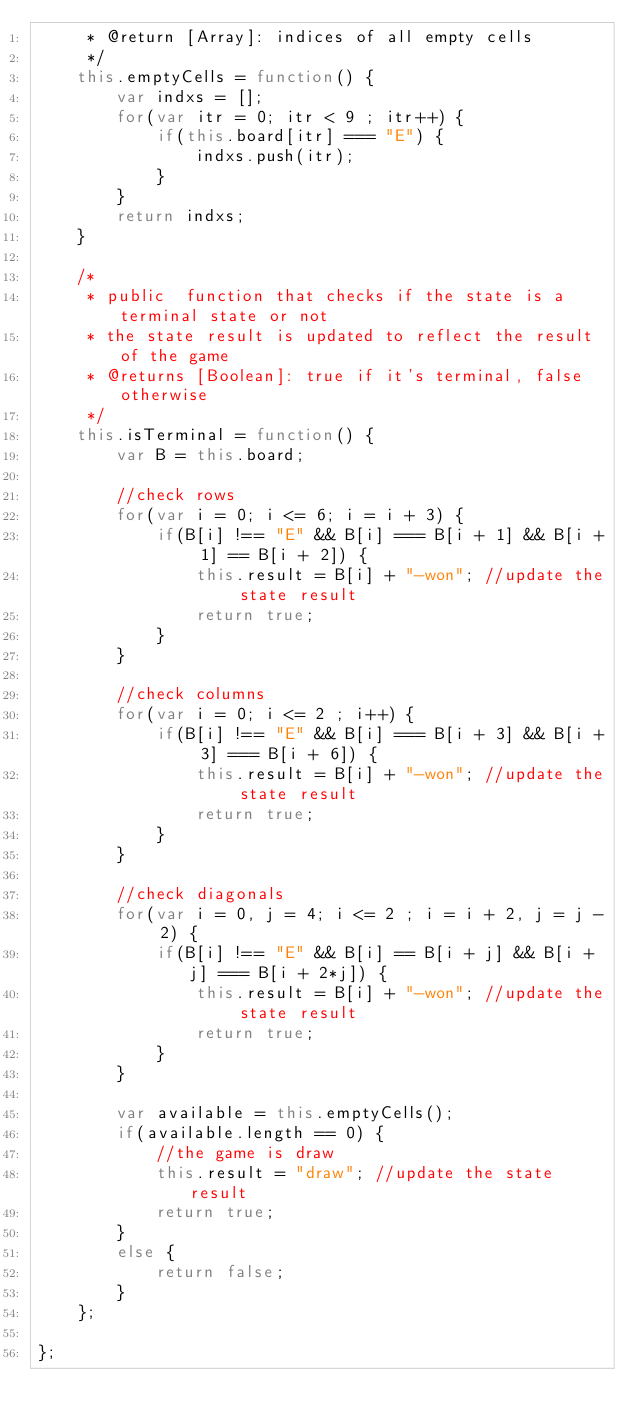Convert code to text. <code><loc_0><loc_0><loc_500><loc_500><_JavaScript_>     * @return [Array]: indices of all empty cells
     */
    this.emptyCells = function() {
        var indxs = [];
        for(var itr = 0; itr < 9 ; itr++) {
            if(this.board[itr] === "E") {
                indxs.push(itr);
            }
        }
        return indxs;
    }

    /*
     * public  function that checks if the state is a terminal state or not
     * the state result is updated to reflect the result of the game
     * @returns [Boolean]: true if it's terminal, false otherwise
     */
    this.isTerminal = function() {
        var B = this.board;

        //check rows
        for(var i = 0; i <= 6; i = i + 3) {
            if(B[i] !== "E" && B[i] === B[i + 1] && B[i + 1] == B[i + 2]) {
                this.result = B[i] + "-won"; //update the state result
                return true;
            }
        }

        //check columns
        for(var i = 0; i <= 2 ; i++) {
            if(B[i] !== "E" && B[i] === B[i + 3] && B[i + 3] === B[i + 6]) {
                this.result = B[i] + "-won"; //update the state result
                return true;
            }
        }

        //check diagonals
        for(var i = 0, j = 4; i <= 2 ; i = i + 2, j = j - 2) {
            if(B[i] !== "E" && B[i] == B[i + j] && B[i + j] === B[i + 2*j]) {
                this.result = B[i] + "-won"; //update the state result
                return true;
            }
        }

        var available = this.emptyCells();
        if(available.length == 0) {
            //the game is draw
            this.result = "draw"; //update the state result
            return true;
        }
        else {
            return false;
        }
    };

};</code> 